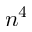Convert formula to latex. <formula><loc_0><loc_0><loc_500><loc_500>n ^ { 4 }</formula> 